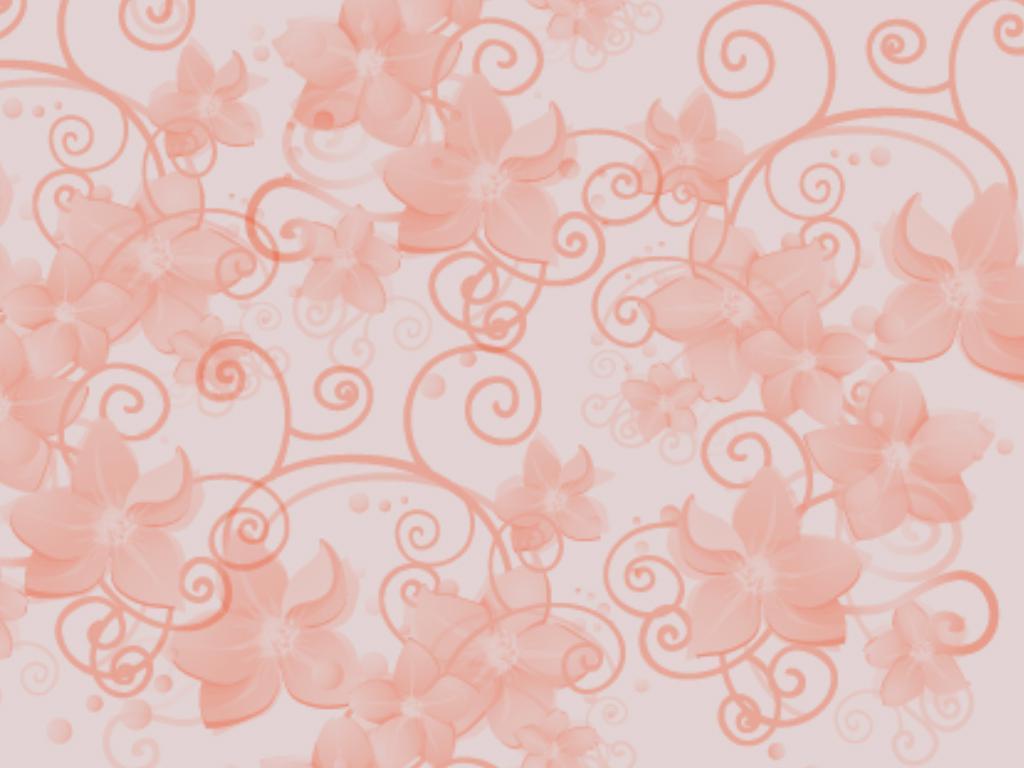In one or two sentences, can you explain what this image depicts? In this image we can see art canvas texture. 